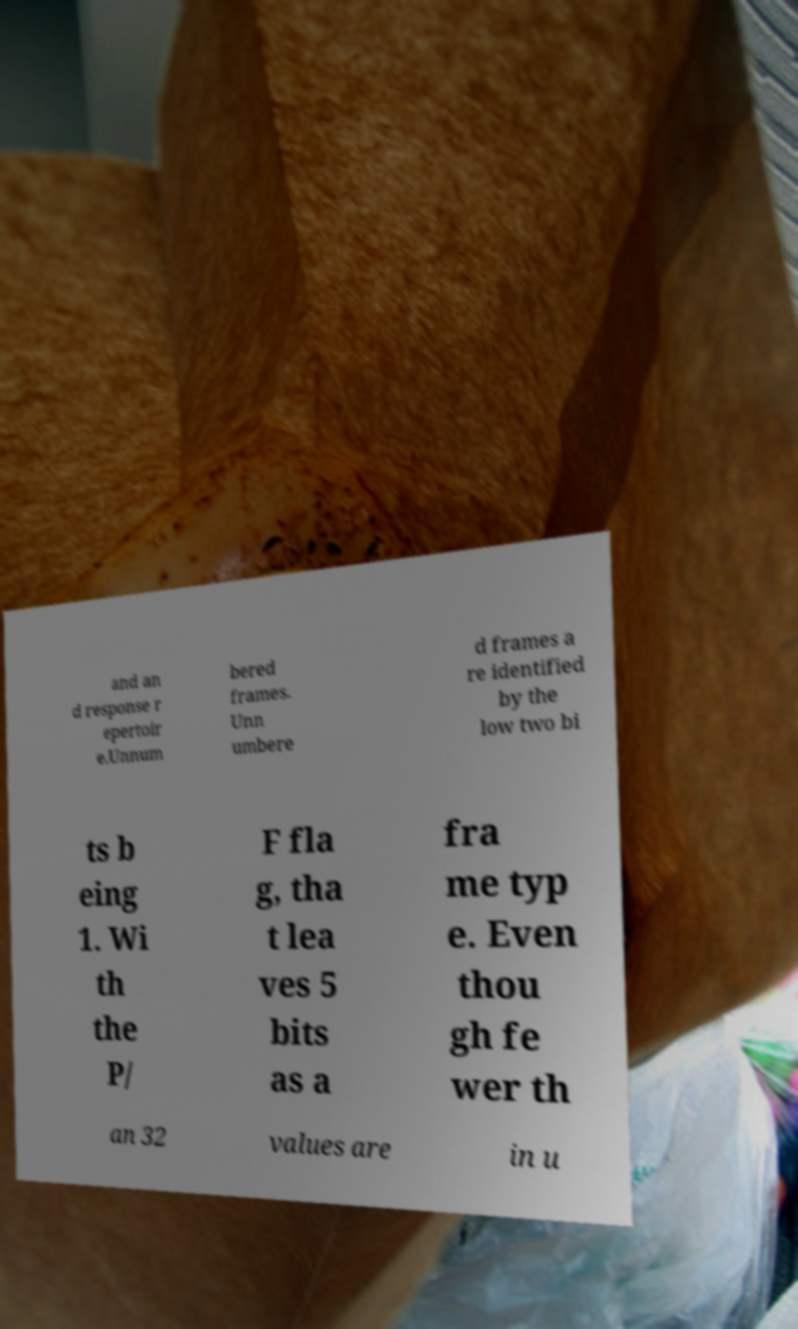For documentation purposes, I need the text within this image transcribed. Could you provide that? and an d response r epertoir e.Unnum bered frames. Unn umbere d frames a re identified by the low two bi ts b eing 1. Wi th the P/ F fla g, tha t lea ves 5 bits as a fra me typ e. Even thou gh fe wer th an 32 values are in u 